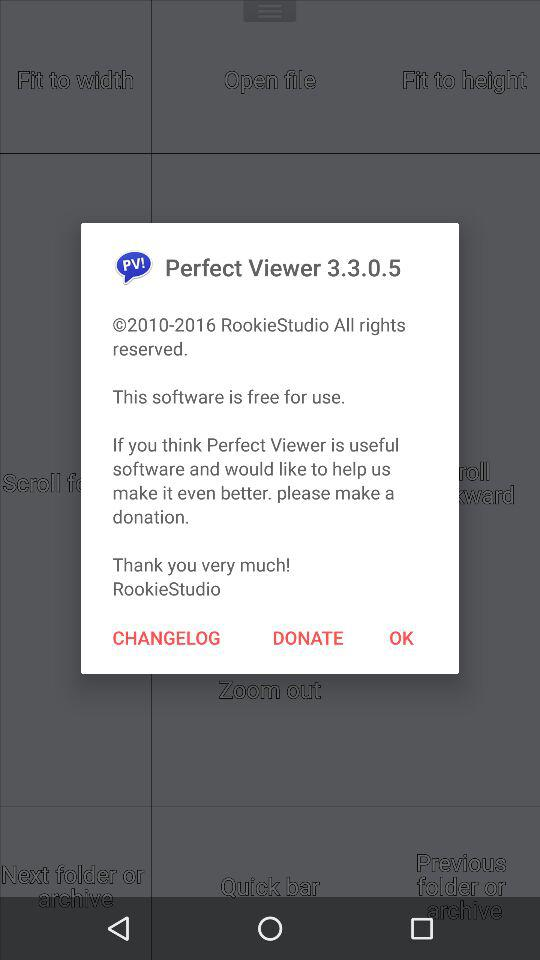What is the version of the application? The version is 3.3.0.5. 